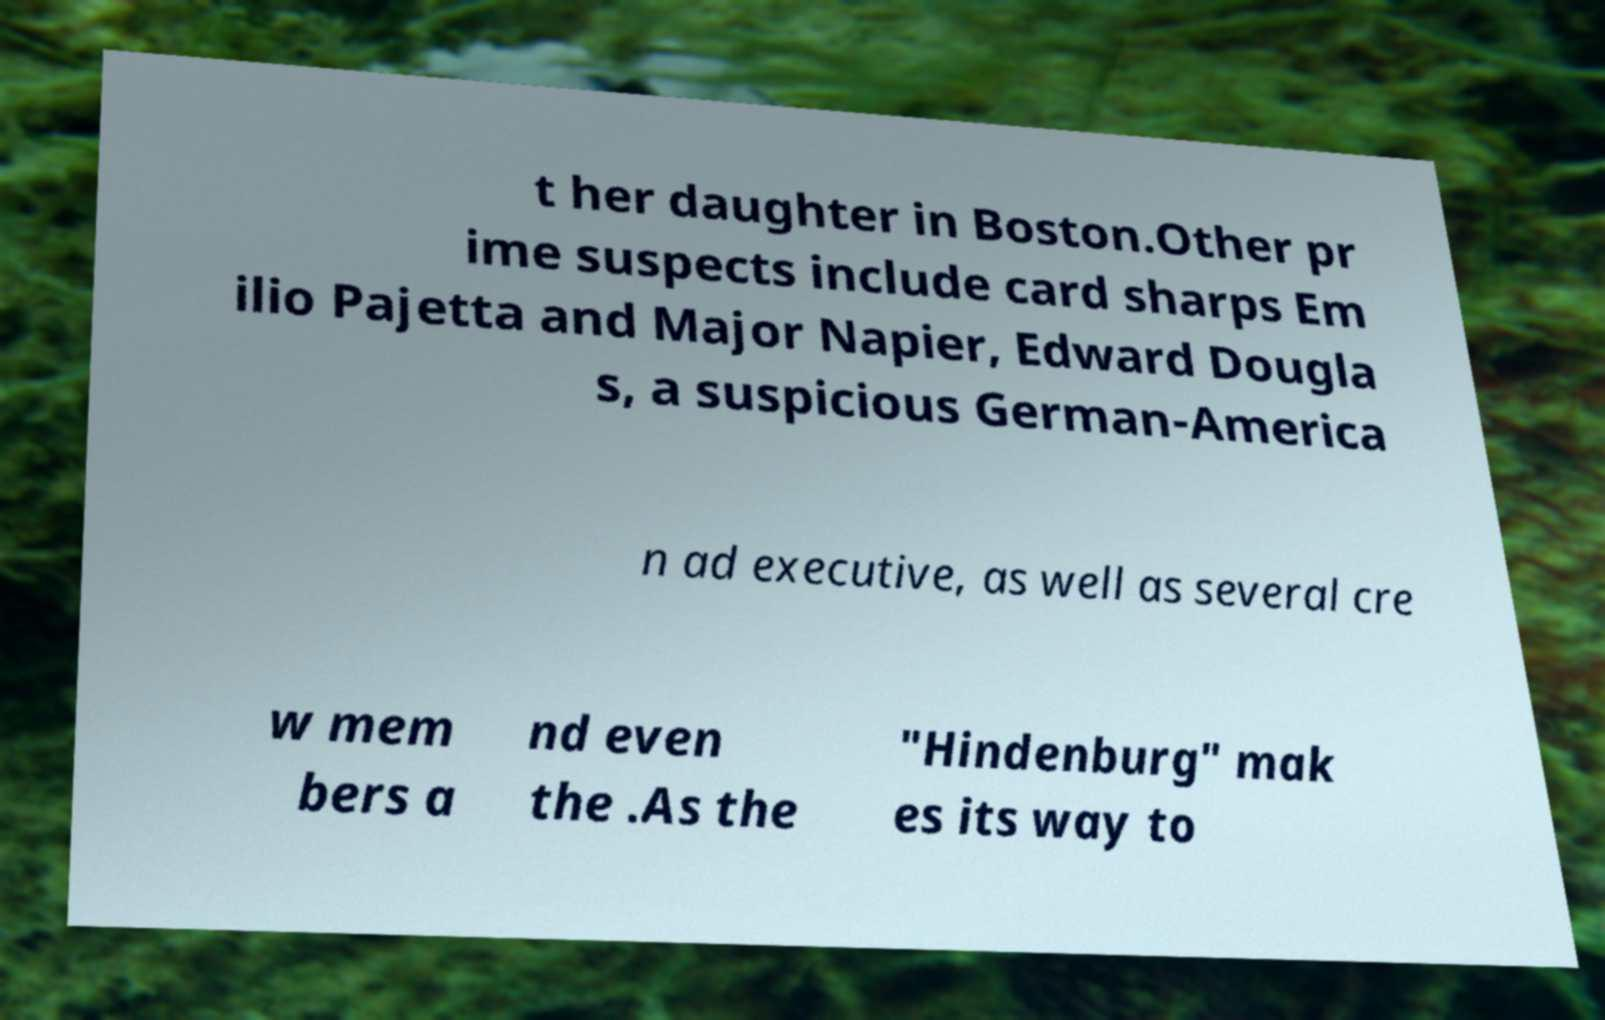I need the written content from this picture converted into text. Can you do that? t her daughter in Boston.Other pr ime suspects include card sharps Em ilio Pajetta and Major Napier, Edward Dougla s, a suspicious German-America n ad executive, as well as several cre w mem bers a nd even the .As the "Hindenburg" mak es its way to 